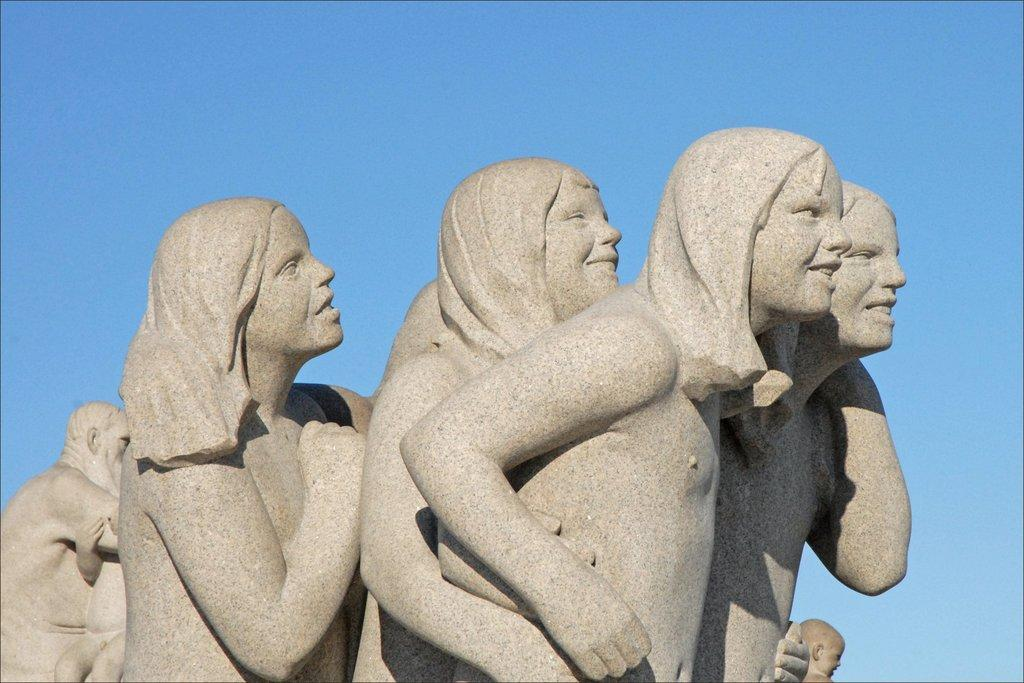What type of artwork is present in the image? There are sculptures in the image. What can be seen in the sky at the top of the image? The sky is visible at the top of the image. What type of invention is depicted in the sculpture? There is no invention depicted in the sculpture; the sculptures are artistic creations. Can you see an owl perched on one of the sculptures in the image? There is no owl present in the image. 